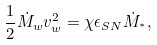<formula> <loc_0><loc_0><loc_500><loc_500>\frac { 1 } { 2 } \dot { M } _ { w } v _ { w } ^ { 2 } = \chi \epsilon _ { S N } \dot { M } _ { ^ { * } } ,</formula> 